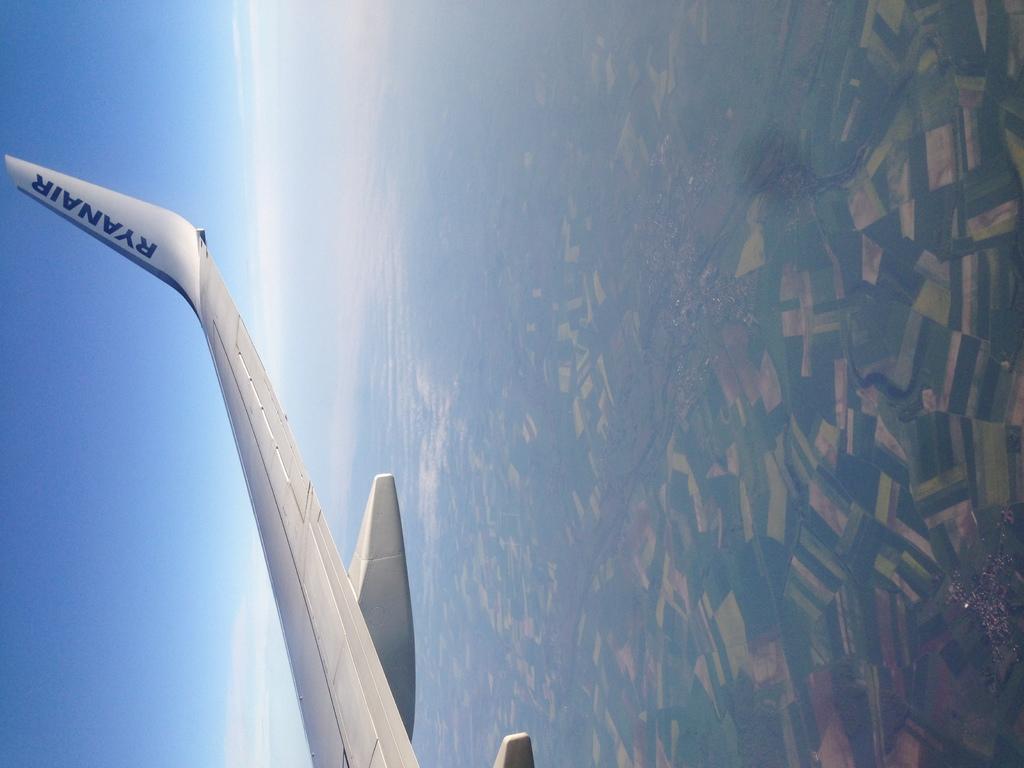What airline is this?
Offer a very short reply. Ryanair. 